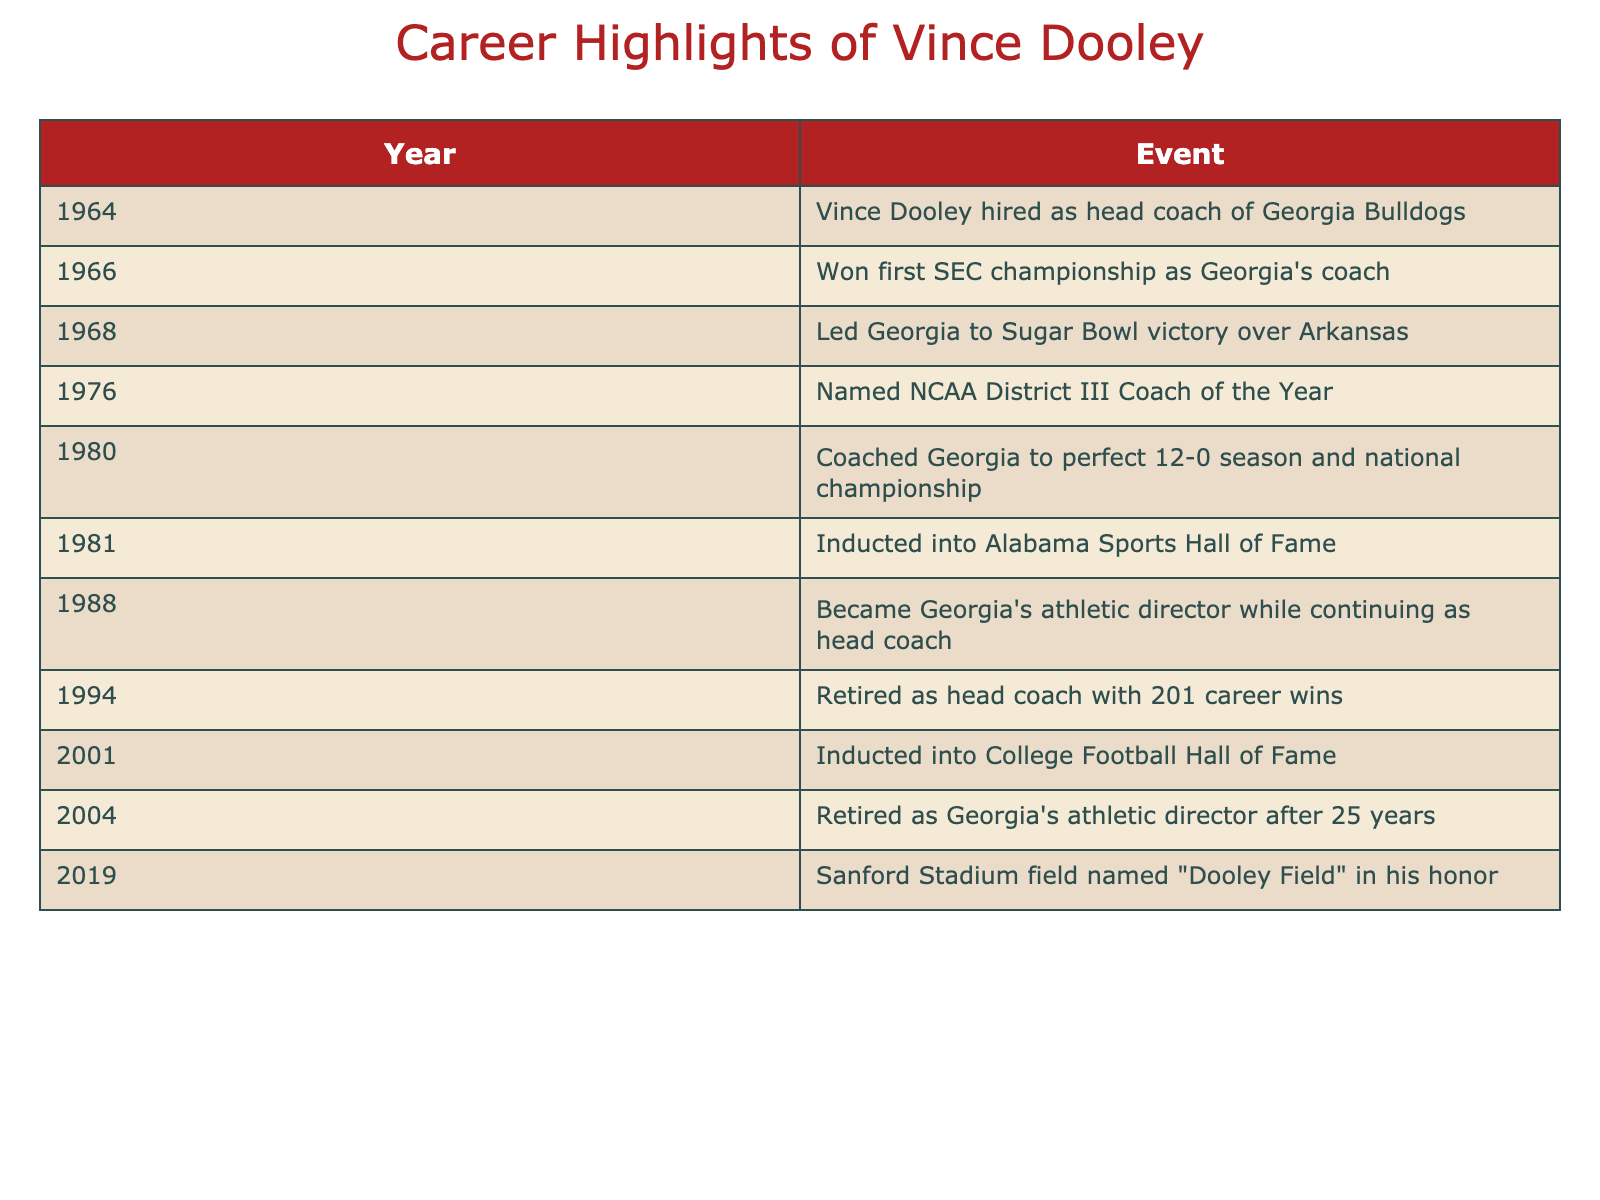What year was Vince Dooley hired as head coach? The table shows the events in chronological order. The first row indicates that Vince Dooley was hired as head coach in the year 1964.
Answer: 1964 How many years did Vince Dooley serve as the head coach before retiring? Vince Dooley was hired in 1964 and retired in 1994. To find the duration, subtract 1964 from 1994, which gives 30 years.
Answer: 30 years Did Vince Dooley lead Georgia to a national championship? According to the table, in 1980, Vince Dooley coached Georgia to a perfect 12-0 season and won the national championship, which confirms the statement is true.
Answer: Yes What event occurred in 2001? The table lists the events by year. In the year 2001, Vince Dooley was inducted into the College Football Hall of Fame.
Answer: Inducted into the College Football Hall of Fame In what year did Vince Dooley become Georgia's athletic director? The table specifies that Vince Dooley became Georgia's athletic director in 1988 while continuing as head coach.
Answer: 1988 How many notable events related to Vince Dooley occurred in the 1980s? Looking at the table, there are three events that occurred in the 1980s: 1980 (national championship), 1981 (induction into Alabama Sports Hall of Fame), and 1988 (becoming athletic director). Thus, the total is three notable events in that decade.
Answer: 3 Was there a significant honor given to Vince Dooley post-retirement? The table indicates that in 2019, Sanford Stadium field was named "Dooley Field" in his honor, confirming that he did receive a significant honor after retirement.
Answer: Yes What was Vince Dooley’s total number of career wins by the time he retired as head coach? The table states that he retired with 201 career wins. Therefore, the total number of career wins is directly given as 201.
Answer: 201 How many years did Vince Dooley serve as Georgia's athletic director? According to the table, he became athletic director in 1988 and retired in 2004. To calculate the duration, subtract 1988 from 2004, yielding 16 years in this role.
Answer: 16 years 